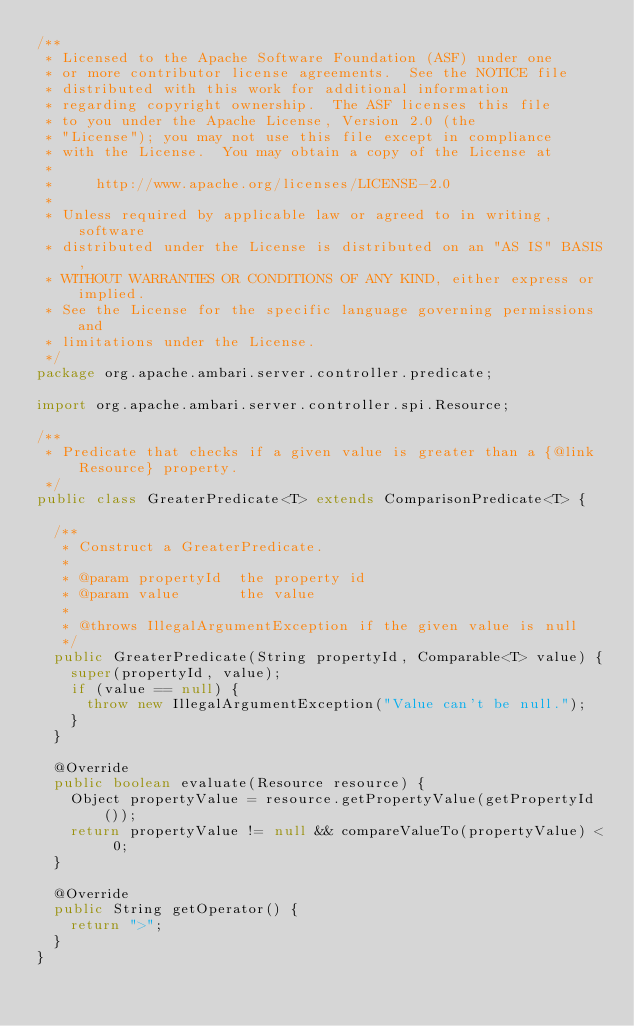Convert code to text. <code><loc_0><loc_0><loc_500><loc_500><_Java_>/**
 * Licensed to the Apache Software Foundation (ASF) under one
 * or more contributor license agreements.  See the NOTICE file
 * distributed with this work for additional information
 * regarding copyright ownership.  The ASF licenses this file
 * to you under the Apache License, Version 2.0 (the
 * "License"); you may not use this file except in compliance
 * with the License.  You may obtain a copy of the License at
 *
 *     http://www.apache.org/licenses/LICENSE-2.0
 *
 * Unless required by applicable law or agreed to in writing, software
 * distributed under the License is distributed on an "AS IS" BASIS,
 * WITHOUT WARRANTIES OR CONDITIONS OF ANY KIND, either express or implied.
 * See the License for the specific language governing permissions and
 * limitations under the License.
 */
package org.apache.ambari.server.controller.predicate;

import org.apache.ambari.server.controller.spi.Resource;

/**
 * Predicate that checks if a given value is greater than a {@link Resource} property.
 */
public class GreaterPredicate<T> extends ComparisonPredicate<T> {

  /**
   * Construct a GreaterPredicate.
   *
   * @param propertyId  the property id
   * @param value       the value
   *
   * @throws IllegalArgumentException if the given value is null
   */
  public GreaterPredicate(String propertyId, Comparable<T> value) {
    super(propertyId, value);
    if (value == null) {
      throw new IllegalArgumentException("Value can't be null.");
    }
  }

  @Override
  public boolean evaluate(Resource resource) {
    Object propertyValue = resource.getPropertyValue(getPropertyId());
    return propertyValue != null && compareValueTo(propertyValue) < 0;
  }

  @Override
  public String getOperator() {
    return ">";
  }
}
</code> 